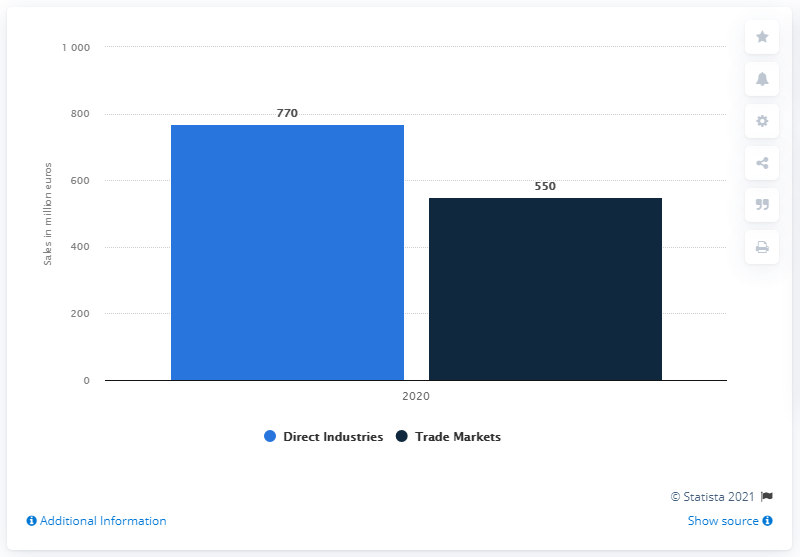Outline some significant characteristics in this image. Tesa's trade markets sales in 2020 were 550. The sales of Tesa's Direct Industries division in 2020 were approximately 770. 